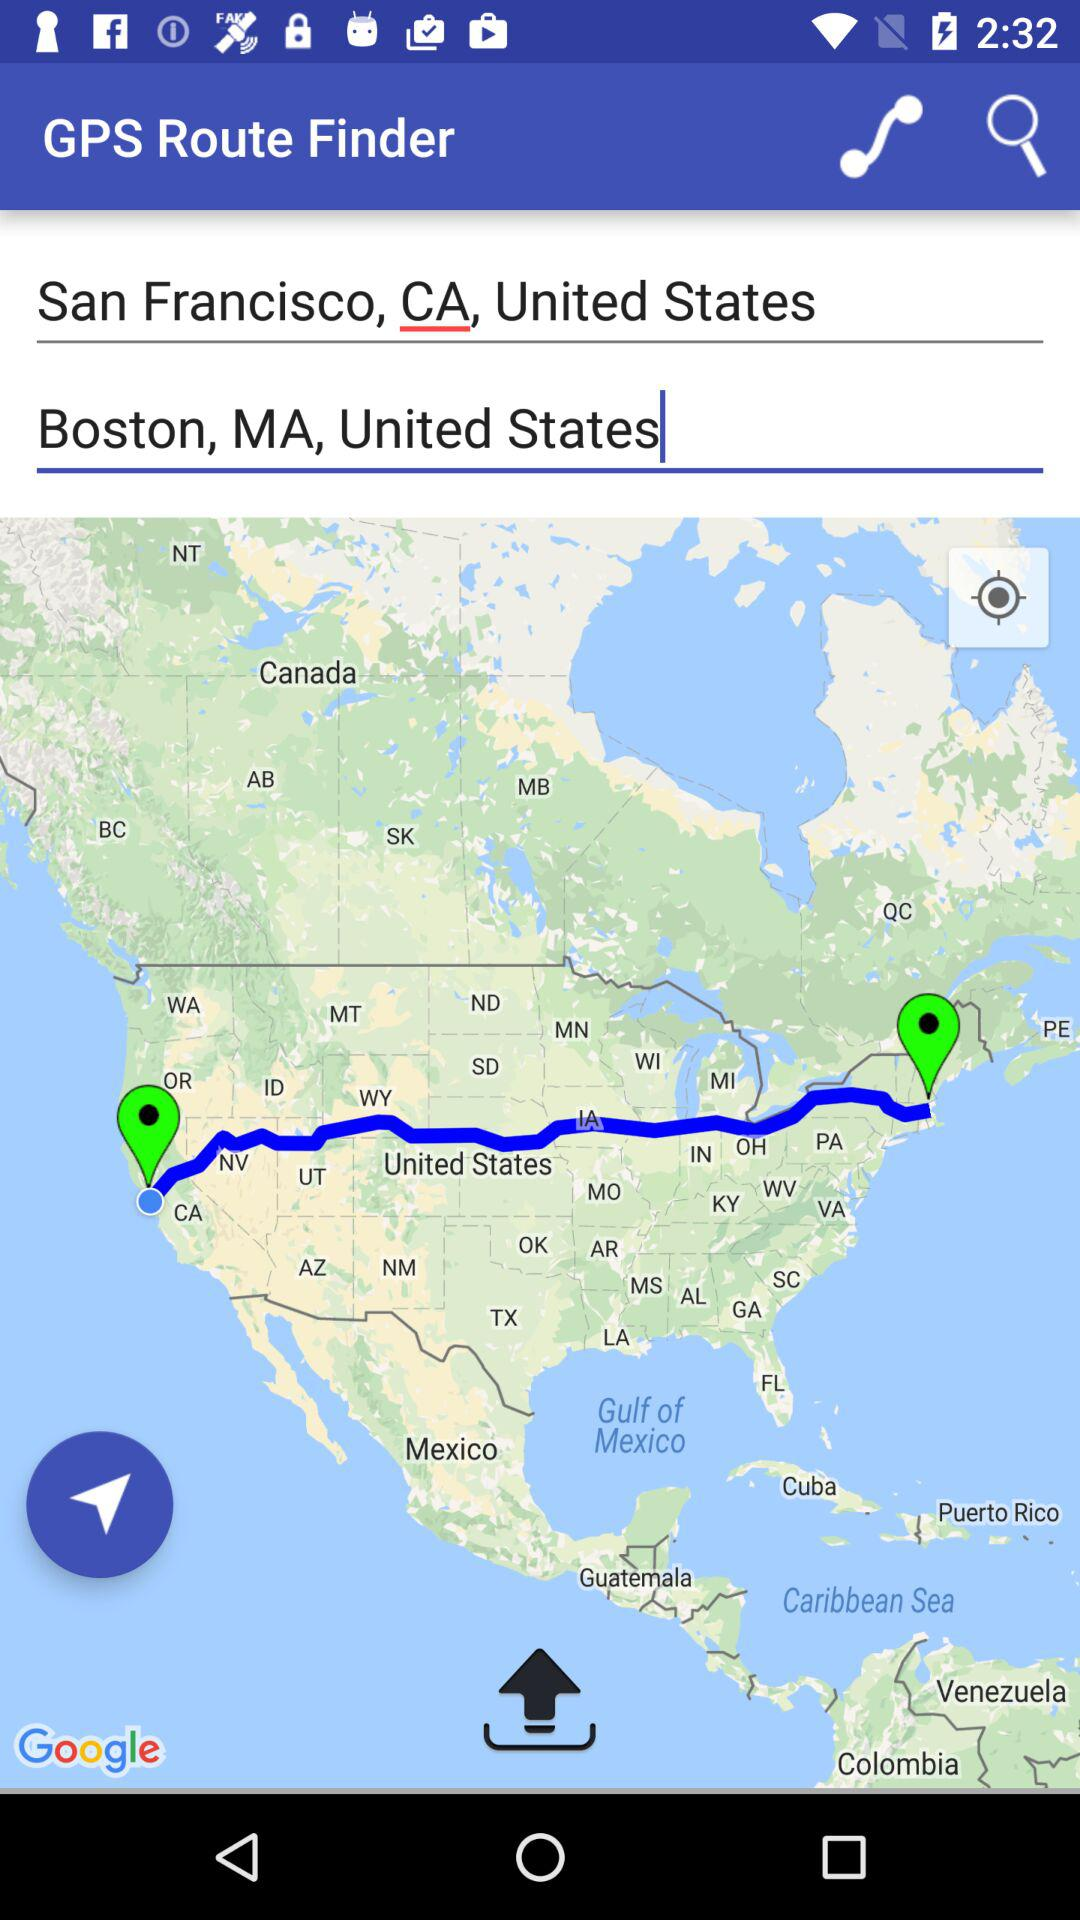What are the locations? The locations are San Francisco, CA, United States and Boston, MA, United States. 